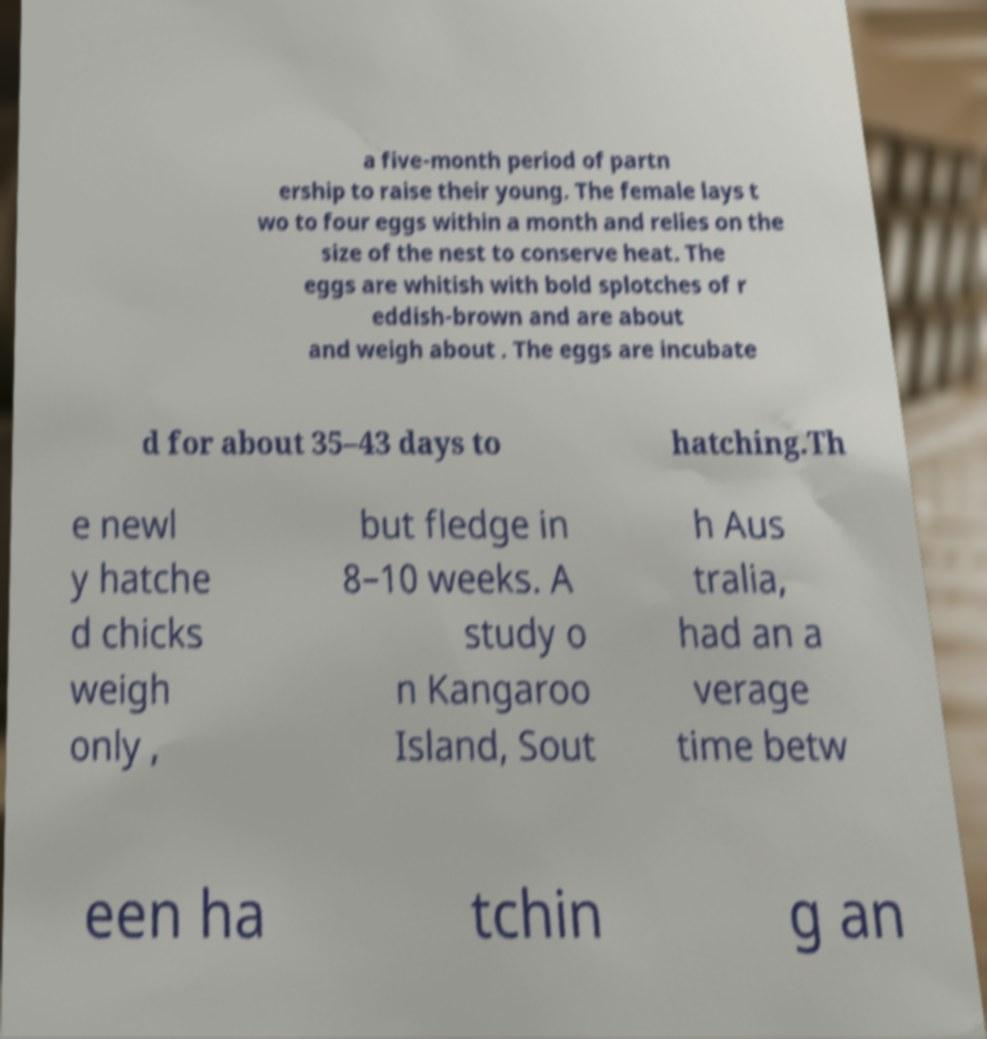I need the written content from this picture converted into text. Can you do that? a five-month period of partn ership to raise their young. The female lays t wo to four eggs within a month and relies on the size of the nest to conserve heat. The eggs are whitish with bold splotches of r eddish-brown and are about and weigh about . The eggs are incubate d for about 35–43 days to hatching.Th e newl y hatche d chicks weigh only , but fledge in 8–10 weeks. A study o n Kangaroo Island, Sout h Aus tralia, had an a verage time betw een ha tchin g an 